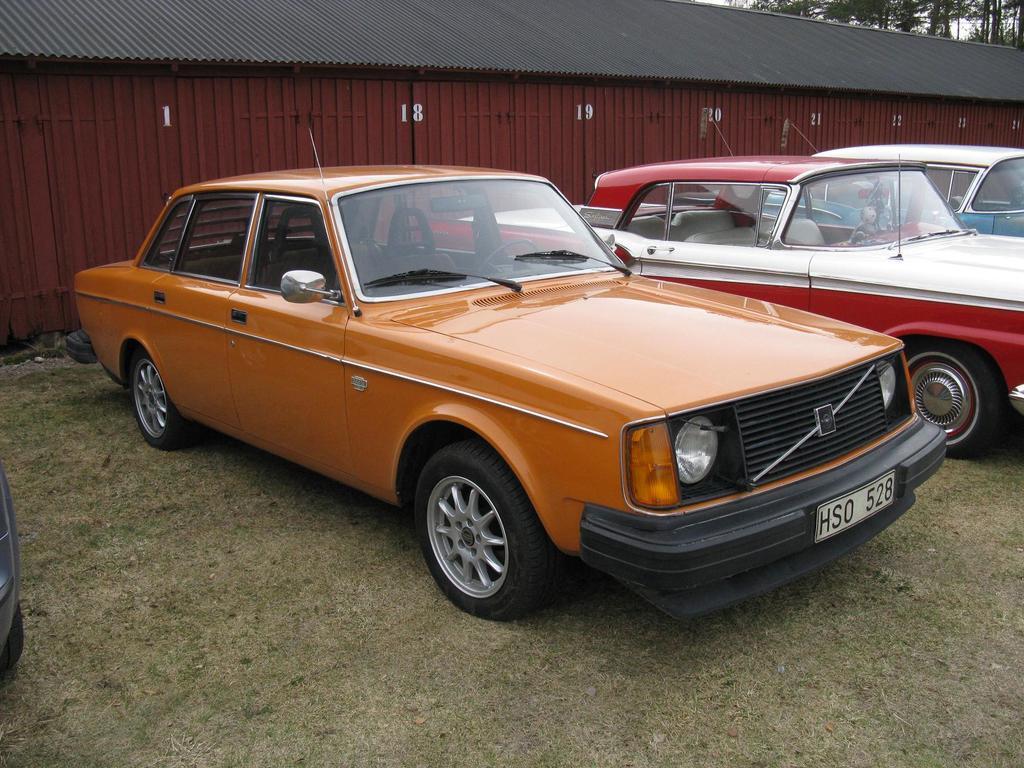Could you give a brief overview of what you see in this image? In the center of the image we can see a few cars in different colors. In the background, we can see trees, one building, wall, roof and grass. On the wall we can see some numbers. 